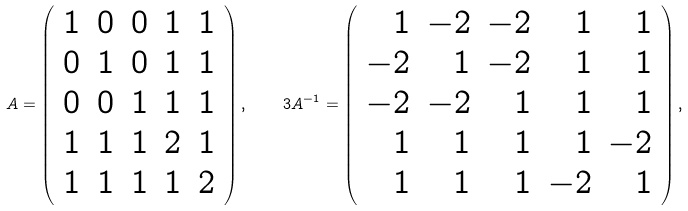Convert formula to latex. <formula><loc_0><loc_0><loc_500><loc_500>A = \left ( \begin{array} { c c c c c } 1 & 0 & 0 & 1 & 1 \\ 0 & 1 & 0 & 1 & 1 \\ 0 & 0 & 1 & 1 & 1 \\ 1 & 1 & 1 & 2 & 1 \\ 1 & 1 & 1 & 1 & 2 \\ \end{array} \right ) , \quad 3 A ^ { - 1 } = \left ( \begin{array} { r r r r r } 1 & - 2 & - 2 & 1 & 1 \\ - 2 & 1 & - 2 & 1 & 1 \\ - 2 & - 2 & 1 & 1 & 1 \\ 1 & 1 & 1 & 1 & - 2 \\ 1 & 1 & 1 & - 2 & 1 \\ \end{array} \right ) ,</formula> 